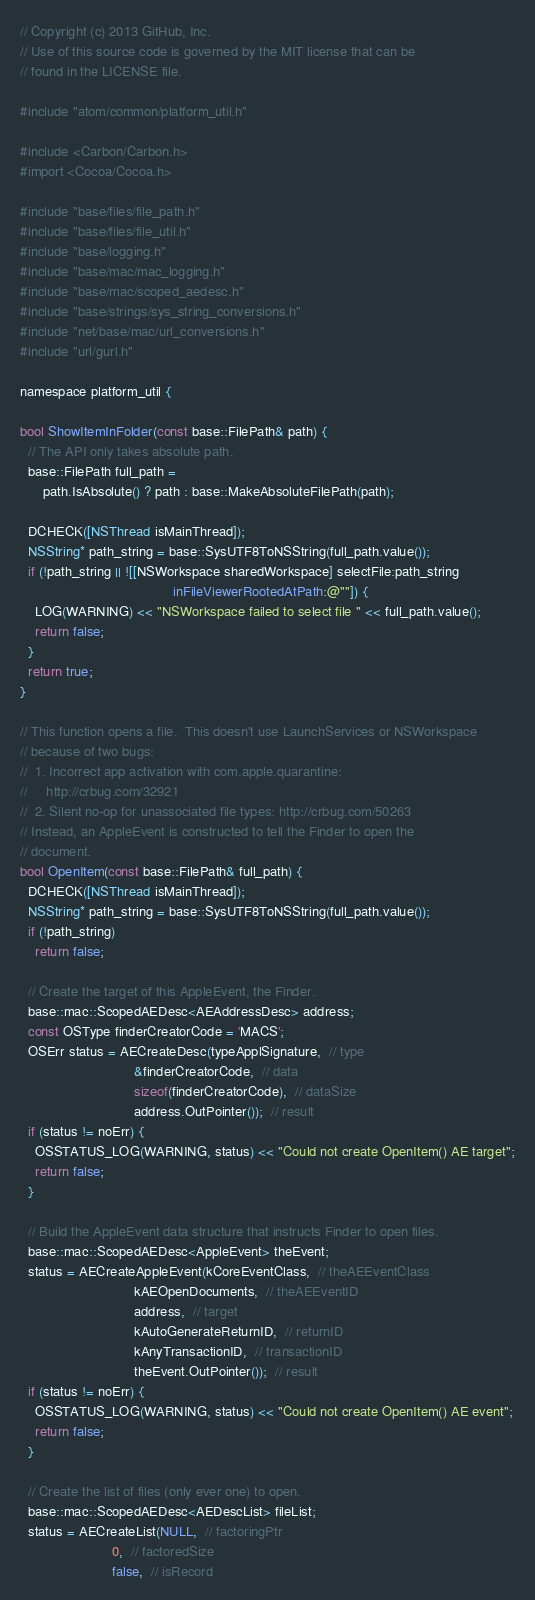Convert code to text. <code><loc_0><loc_0><loc_500><loc_500><_ObjectiveC_>// Copyright (c) 2013 GitHub, Inc.
// Use of this source code is governed by the MIT license that can be
// found in the LICENSE file.

#include "atom/common/platform_util.h"

#include <Carbon/Carbon.h>
#import <Cocoa/Cocoa.h>

#include "base/files/file_path.h"
#include "base/files/file_util.h"
#include "base/logging.h"
#include "base/mac/mac_logging.h"
#include "base/mac/scoped_aedesc.h"
#include "base/strings/sys_string_conversions.h"
#include "net/base/mac/url_conversions.h"
#include "url/gurl.h"

namespace platform_util {

bool ShowItemInFolder(const base::FilePath& path) {
  // The API only takes absolute path.
  base::FilePath full_path =
      path.IsAbsolute() ? path : base::MakeAbsoluteFilePath(path);

  DCHECK([NSThread isMainThread]);
  NSString* path_string = base::SysUTF8ToNSString(full_path.value());
  if (!path_string || ![[NSWorkspace sharedWorkspace] selectFile:path_string
                                        inFileViewerRootedAtPath:@""]) {
    LOG(WARNING) << "NSWorkspace failed to select file " << full_path.value();
    return false;
  }
  return true;
}

// This function opens a file.  This doesn't use LaunchServices or NSWorkspace
// because of two bugs:
//  1. Incorrect app activation with com.apple.quarantine:
//     http://crbug.com/32921
//  2. Silent no-op for unassociated file types: http://crbug.com/50263
// Instead, an AppleEvent is constructed to tell the Finder to open the
// document.
bool OpenItem(const base::FilePath& full_path) {
  DCHECK([NSThread isMainThread]);
  NSString* path_string = base::SysUTF8ToNSString(full_path.value());
  if (!path_string)
    return false;

  // Create the target of this AppleEvent, the Finder.
  base::mac::ScopedAEDesc<AEAddressDesc> address;
  const OSType finderCreatorCode = 'MACS';
  OSErr status = AECreateDesc(typeApplSignature,  // type
                              &finderCreatorCode,  // data
                              sizeof(finderCreatorCode),  // dataSize
                              address.OutPointer());  // result
  if (status != noErr) {
    OSSTATUS_LOG(WARNING, status) << "Could not create OpenItem() AE target";
    return false;
  }

  // Build the AppleEvent data structure that instructs Finder to open files.
  base::mac::ScopedAEDesc<AppleEvent> theEvent;
  status = AECreateAppleEvent(kCoreEventClass,  // theAEEventClass
                              kAEOpenDocuments,  // theAEEventID
                              address,  // target
                              kAutoGenerateReturnID,  // returnID
                              kAnyTransactionID,  // transactionID
                              theEvent.OutPointer());  // result
  if (status != noErr) {
    OSSTATUS_LOG(WARNING, status) << "Could not create OpenItem() AE event";
    return false;
  }

  // Create the list of files (only ever one) to open.
  base::mac::ScopedAEDesc<AEDescList> fileList;
  status = AECreateList(NULL,  // factoringPtr
                        0,  // factoredSize
                        false,  // isRecord</code> 